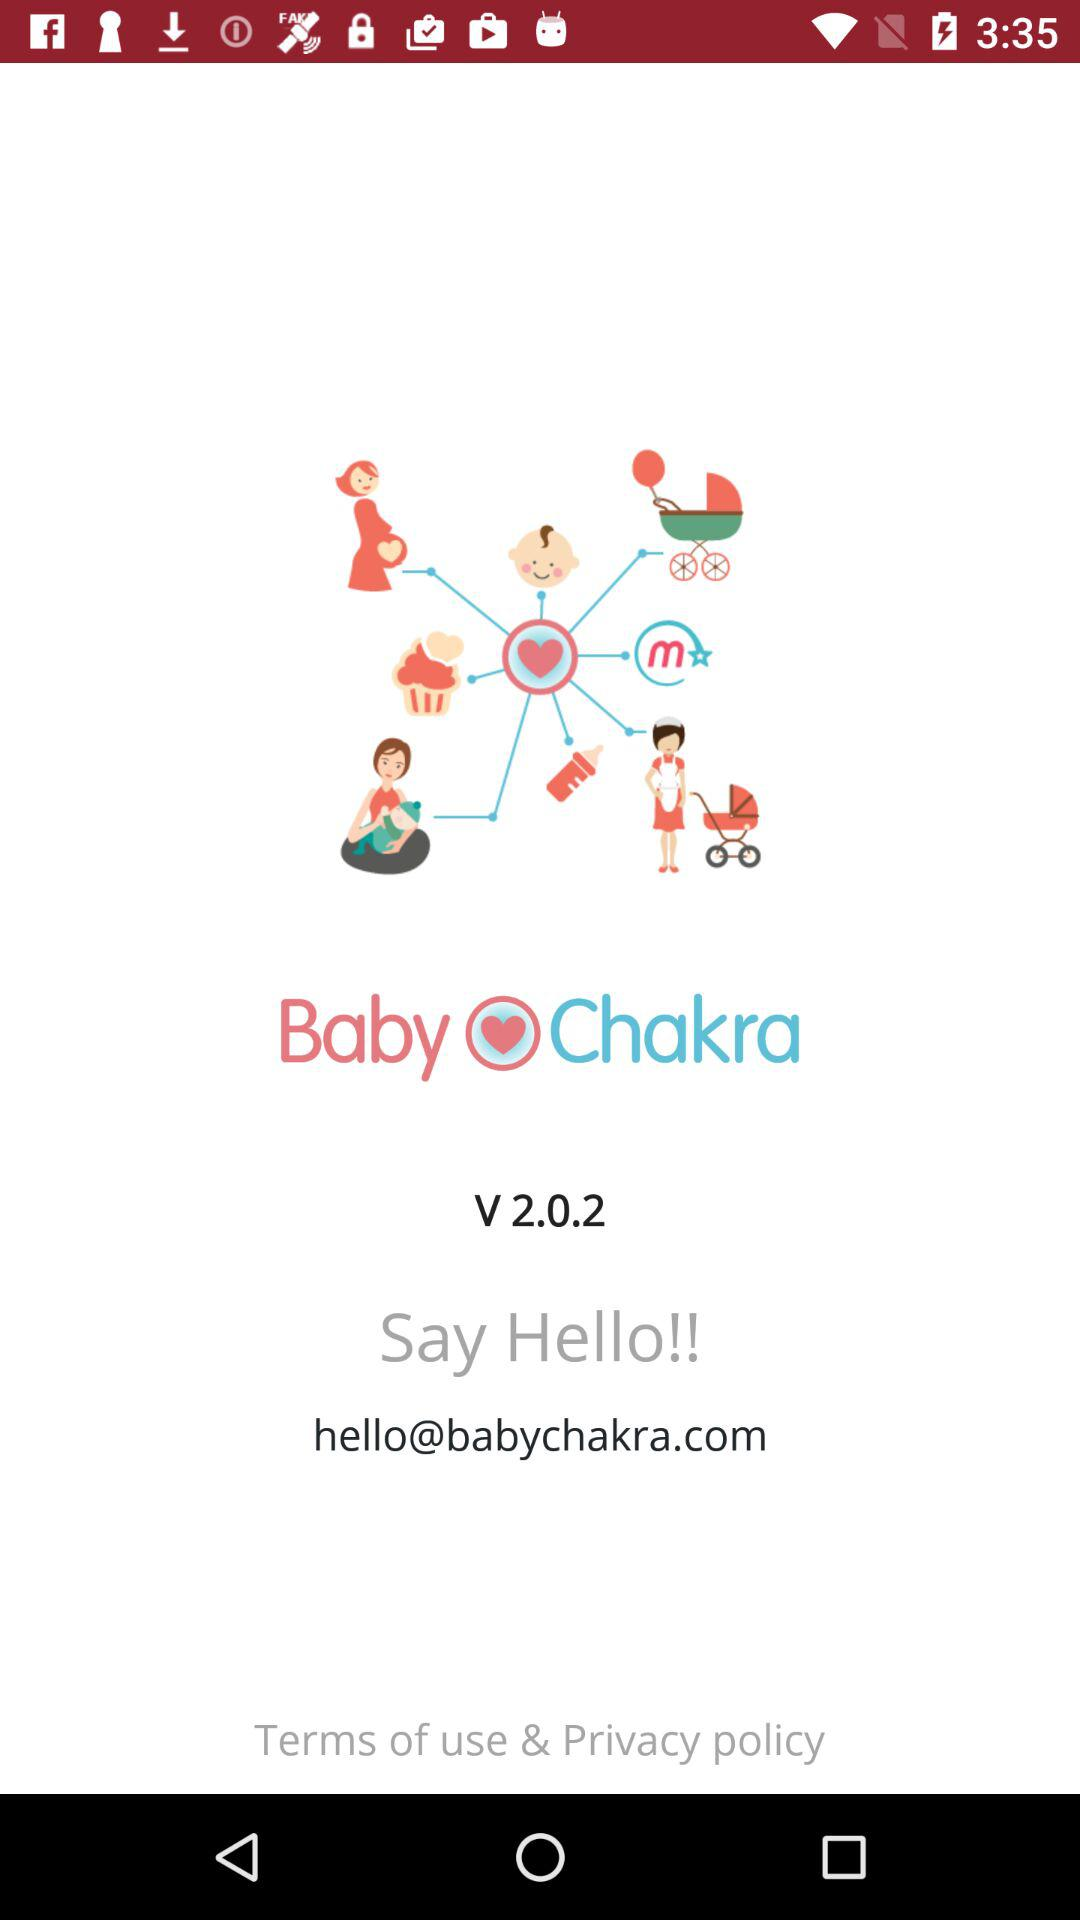What is the shown email address? The shown email address is hello@babychakra.com. 